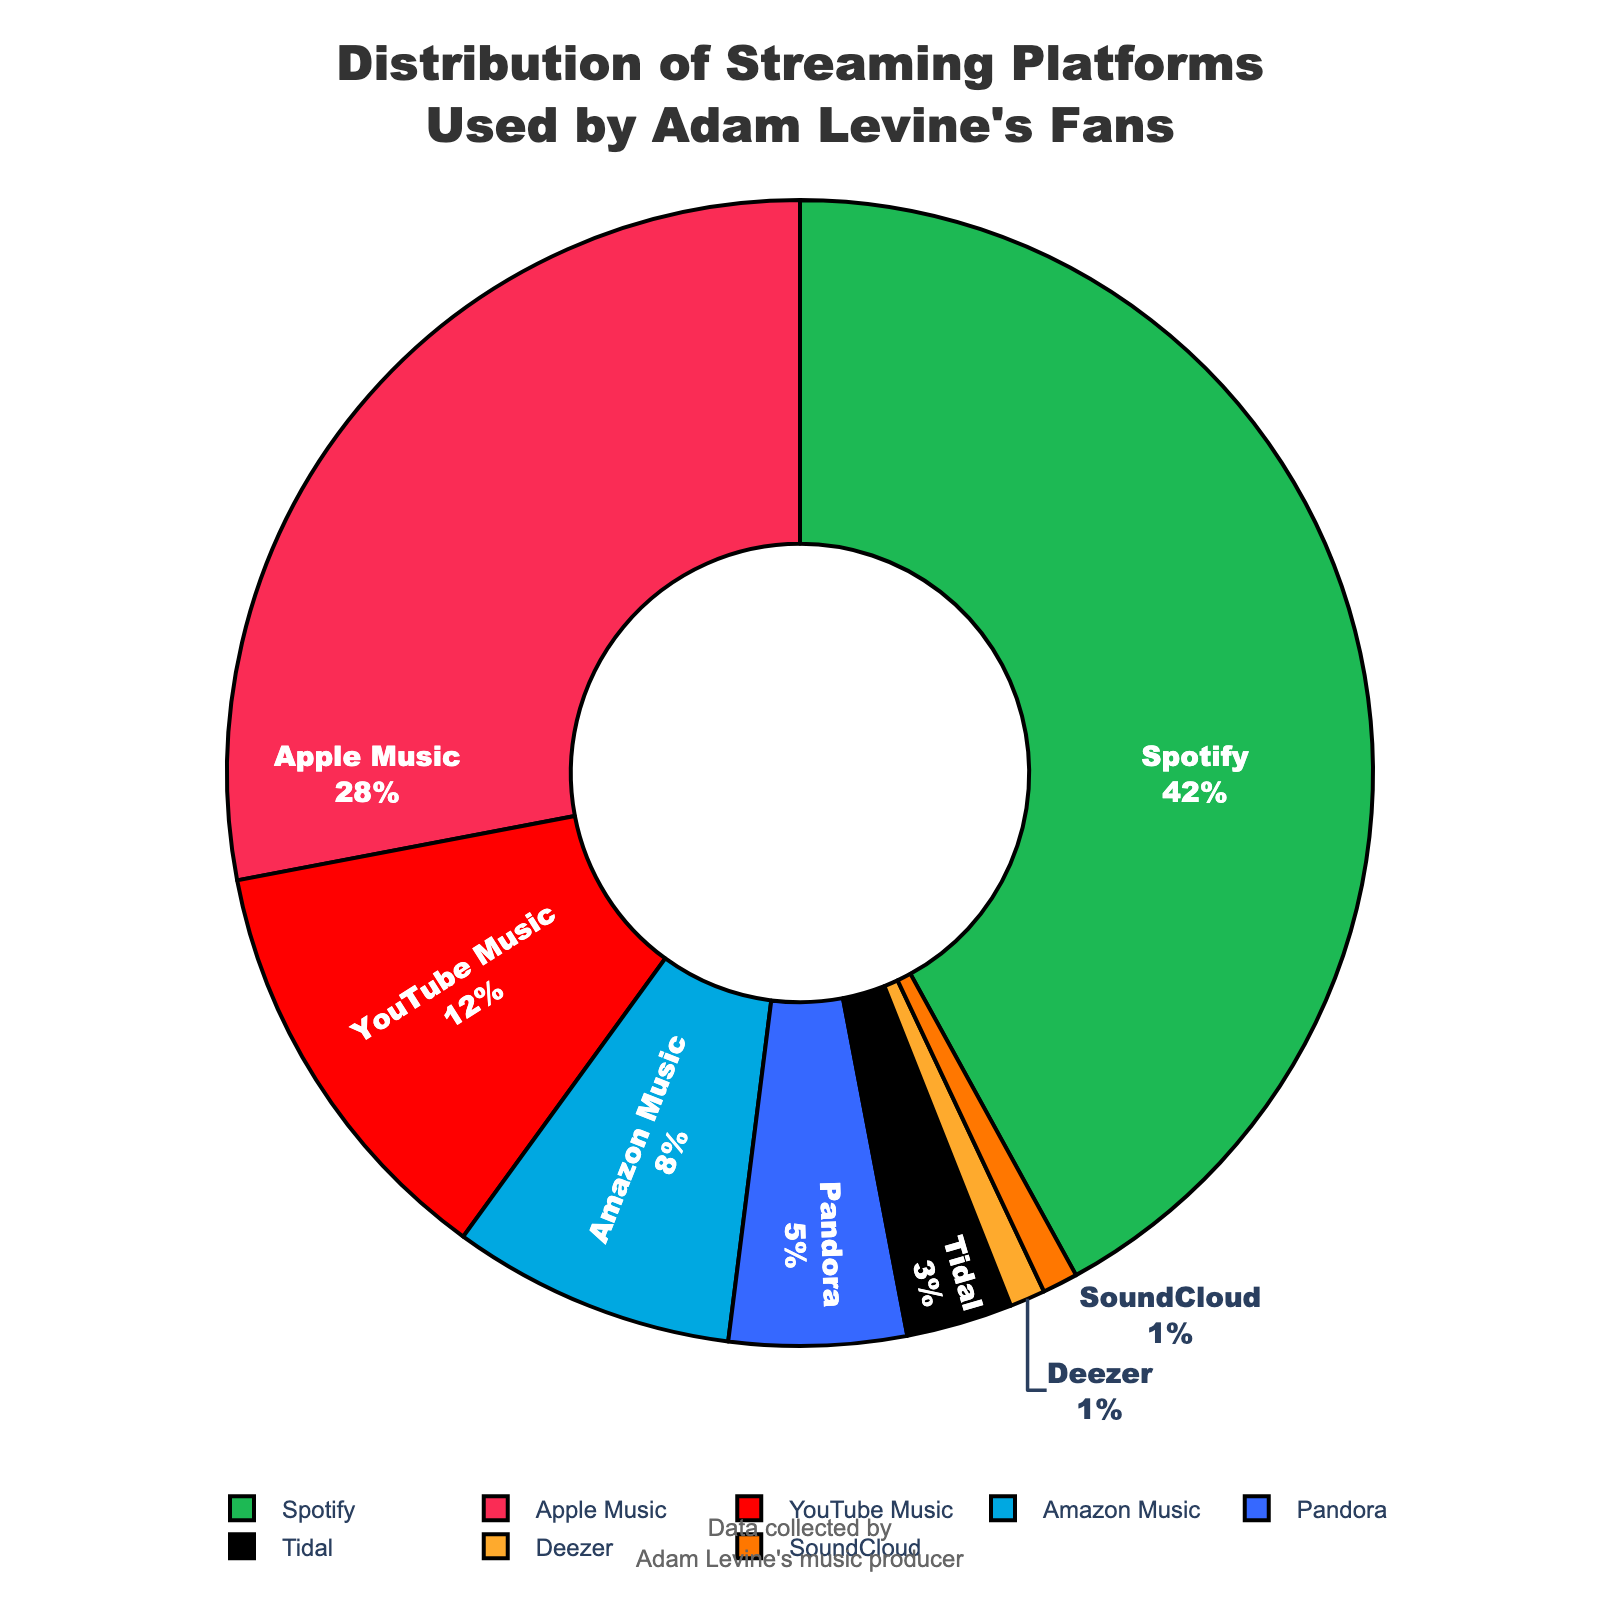What is the most popular streaming platform among Adam Levine's fans? Spotify has the highest percentage at 42%. This is directly visible from the pie chart where Spotify occupies the largest segment.
Answer: Spotify Which streaming platform ranks second in usage? Apple Music has the second-highest usage at 28%. This can be observed from the pie chart where it has the second-largest segment.
Answer: Apple Music Are there any streaming platforms with the same percentage of users? Deezer and SoundCloud both have 1% of users, as shown in the pie chart where both segments are represented equally.
Answer: Deezer and SoundCloud What is the combined percentage of fans using Amazon Music and Pandora? The percentages for Amazon Music and Pandora are 8% and 5%, respectively. Adding them together gives 8% + 5% = 13%.
Answer: 13% Is YouTube Music more or less popular than Tidal? YouTube Music is more popular than Tidal. YouTube Music has 12%, while Tidal has only 3%, as shown in the pie chart.
Answer: More Which color represents YouTube Music on the pie chart? The color representing YouTube Music is red. This can be visually verified by looking at the corresponding segment in the pie chart.
Answer: Red What is the least popular streaming platform among Adam Levine's fans? Deezer and SoundCloud are the least popular, each with 1%, as indicated by the smallest segments in the pie chart.
Answer: Deezer and SoundCloud What is the difference in percentage between Spotify and Amazon Music? Spotify has 42% and Amazon Music has 8%. The difference is calculated as 42% - 8% = 34%.
Answer: 34% How much more popular is Spotify compared to YouTube Music? Spotify has 42%, and YouTube Music has 12%. The difference is 42% - 12% = 30%.
Answer: 30% What percentage of Adam Levine's fans use platforms other than Spotify and Apple Music? Spotify and Apple Music together account for 42% + 28% = 70%. Therefore, the remaining percentage is 100% - 70% = 30%.
Answer: 30% 